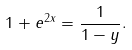Convert formula to latex. <formula><loc_0><loc_0><loc_500><loc_500>1 + e ^ { 2 x } = \frac { 1 } { 1 - y } .</formula> 